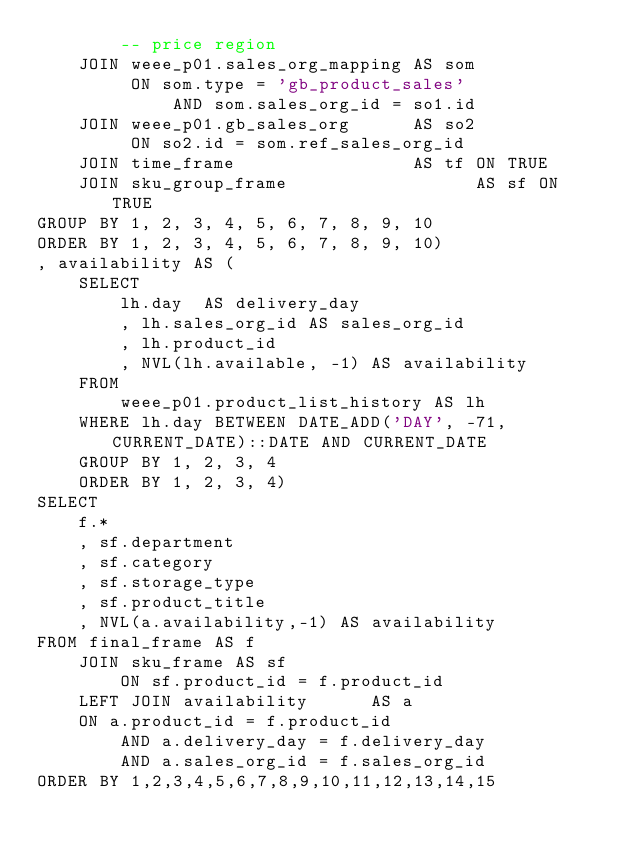<code> <loc_0><loc_0><loc_500><loc_500><_SQL_>        -- price region
    JOIN weee_p01.sales_org_mapping AS som
         ON som.type = 'gb_product_sales'
             AND som.sales_org_id = so1.id
    JOIN weee_p01.gb_sales_org      AS so2
         ON so2.id = som.ref_sales_org_id
    JOIN time_frame                 AS tf ON TRUE
    JOIN sku_group_frame                  AS sf ON TRUE
GROUP BY 1, 2, 3, 4, 5, 6, 7, 8, 9, 10
ORDER BY 1, 2, 3, 4, 5, 6, 7, 8, 9, 10)
, availability AS (
    SELECT
        lh.day  AS delivery_day
        , lh.sales_org_id AS sales_org_id
        , lh.product_id
        , NVL(lh.available, -1) AS availability
    FROM
        weee_p01.product_list_history AS lh
    WHERE lh.day BETWEEN DATE_ADD('DAY', -71, CURRENT_DATE)::DATE AND CURRENT_DATE
    GROUP BY 1, 2, 3, 4
    ORDER BY 1, 2, 3, 4)
SELECT
    f.*
    , sf.department
    , sf.category
    , sf.storage_type
    , sf.product_title
    , NVL(a.availability,-1) AS availability
FROM final_frame AS f
    JOIN sku_frame AS sf
        ON sf.product_id = f.product_id
    LEFT JOIN availability      AS a
    ON a.product_id = f.product_id
        AND a.delivery_day = f.delivery_day
        AND a.sales_org_id = f.sales_org_id
ORDER BY 1,2,3,4,5,6,7,8,9,10,11,12,13,14,15
</code> 